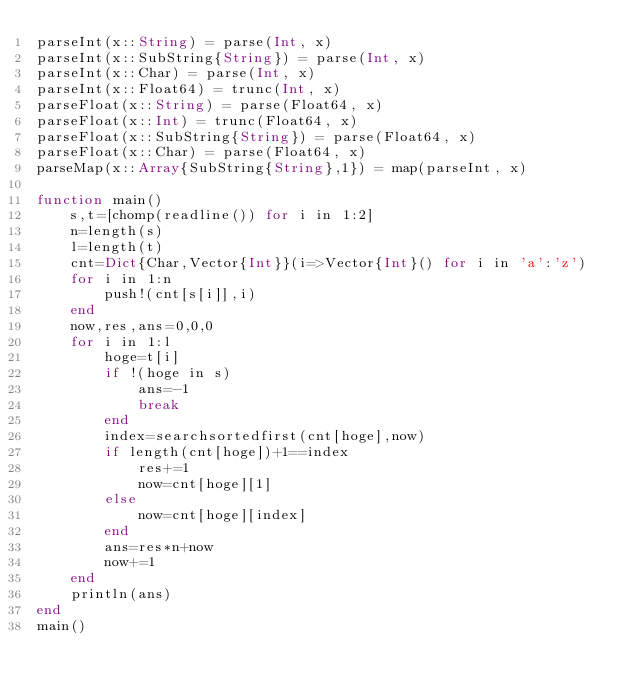Convert code to text. <code><loc_0><loc_0><loc_500><loc_500><_Julia_>parseInt(x::String) = parse(Int, x)
parseInt(x::SubString{String}) = parse(Int, x)
parseInt(x::Char) = parse(Int, x)
parseInt(x::Float64) = trunc(Int, x)
parseFloat(x::String) = parse(Float64, x)
parseFloat(x::Int) = trunc(Float64, x)
parseFloat(x::SubString{String}) = parse(Float64, x)
parseFloat(x::Char) = parse(Float64, x)
parseMap(x::Array{SubString{String},1}) = map(parseInt, x)

function main()
    s,t=[chomp(readline()) for i in 1:2]
    n=length(s)
    l=length(t)
    cnt=Dict{Char,Vector{Int}}(i=>Vector{Int}() for i in 'a':'z')
    for i in 1:n
        push!(cnt[s[i]],i)
    end
    now,res,ans=0,0,0
    for i in 1:l
        hoge=t[i]
        if !(hoge in s)
            ans=-1
            break
        end
        index=searchsortedfirst(cnt[hoge],now)
        if length(cnt[hoge])+1==index
            res+=1
            now=cnt[hoge][1]
        else
            now=cnt[hoge][index]
        end
        ans=res*n+now
        now+=1
    end
    println(ans)
end
main()</code> 